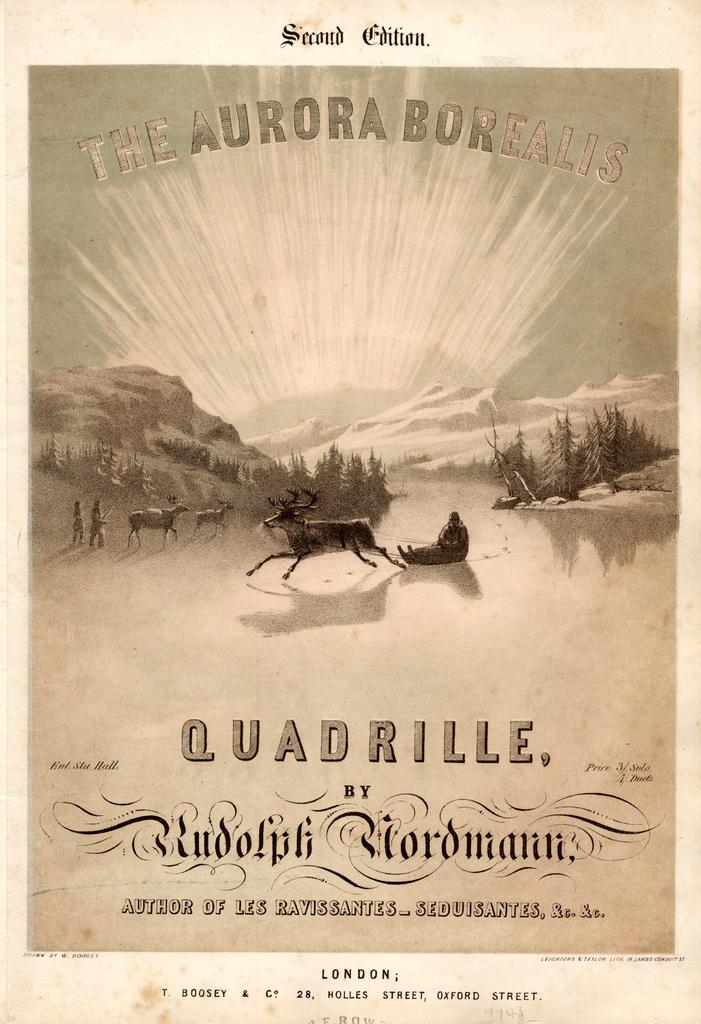<image>
Write a terse but informative summary of the picture. an old fashioned photo for quadrille by rudolph nordmann 